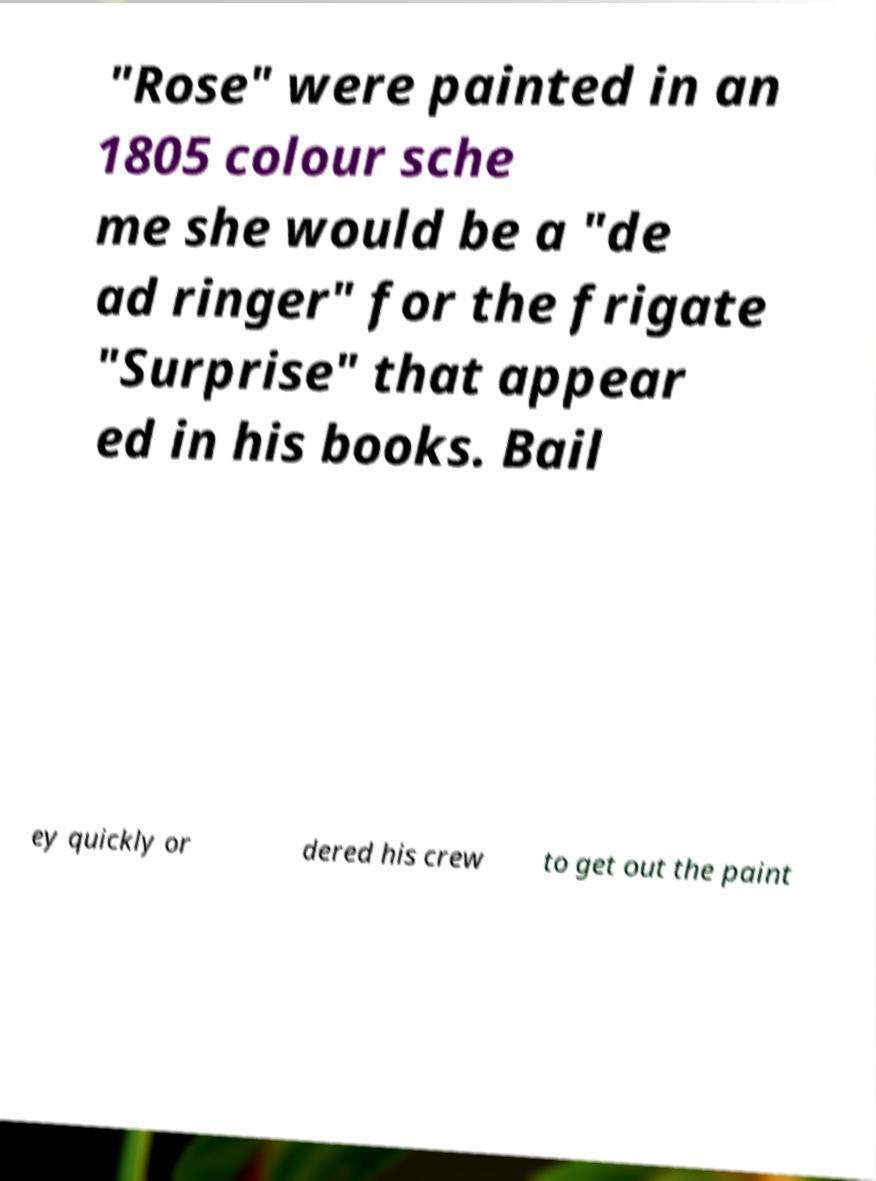For documentation purposes, I need the text within this image transcribed. Could you provide that? "Rose" were painted in an 1805 colour sche me she would be a "de ad ringer" for the frigate "Surprise" that appear ed in his books. Bail ey quickly or dered his crew to get out the paint 